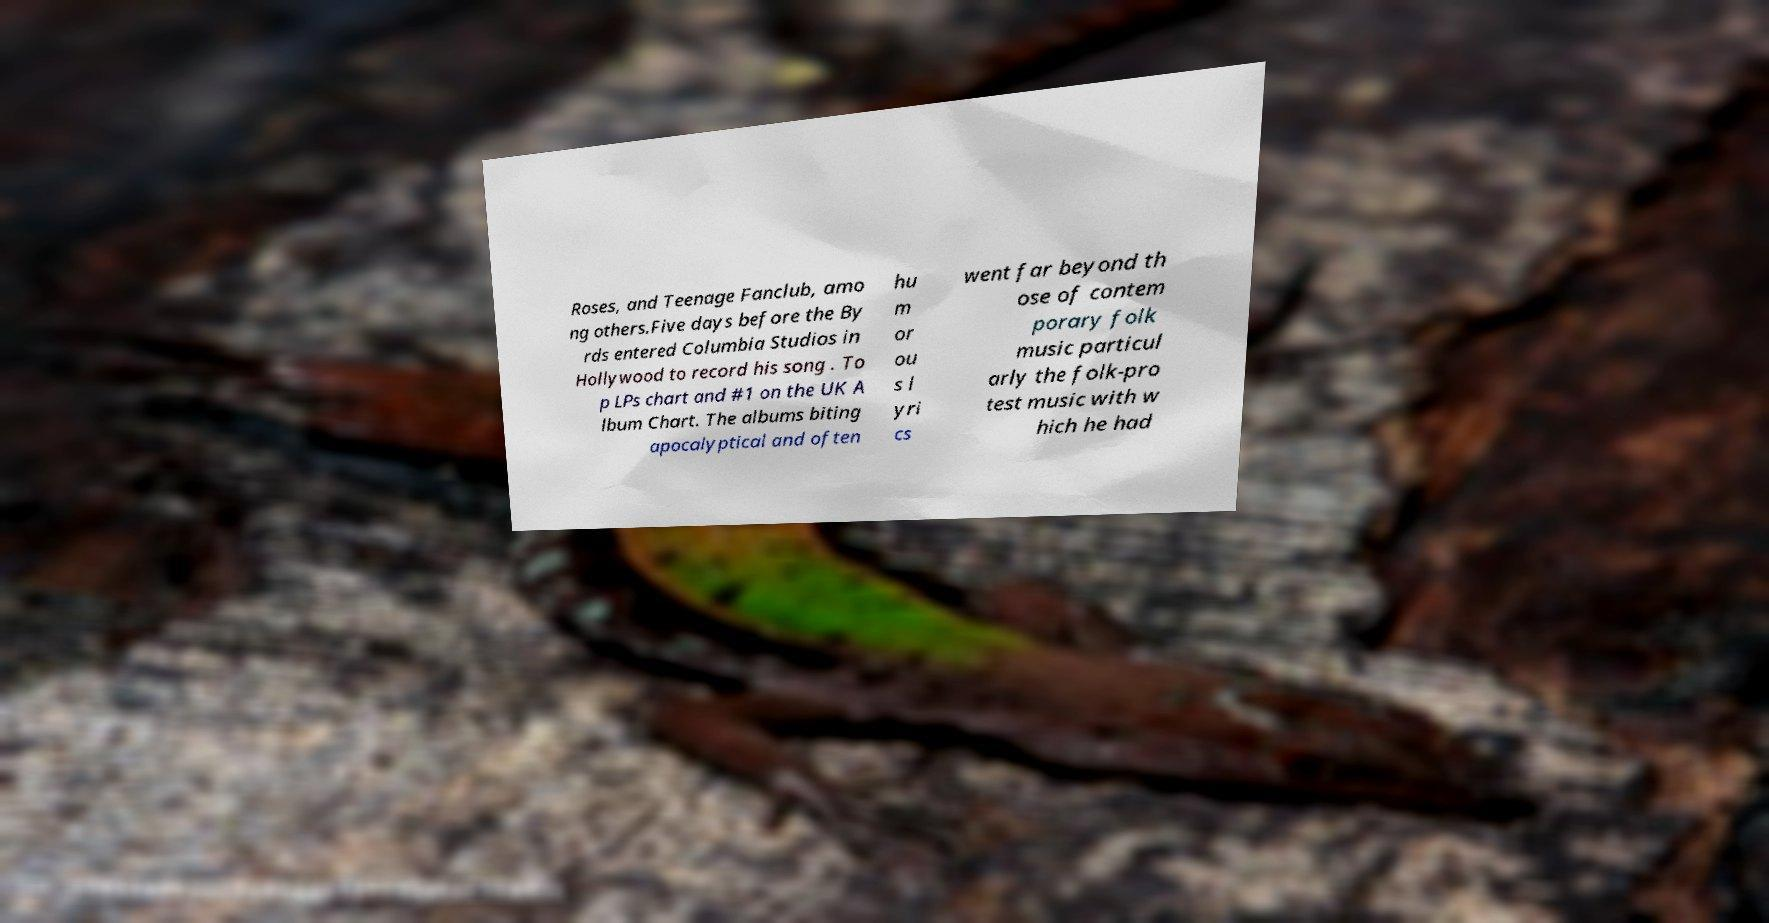Could you assist in decoding the text presented in this image and type it out clearly? Roses, and Teenage Fanclub, amo ng others.Five days before the By rds entered Columbia Studios in Hollywood to record his song . To p LPs chart and #1 on the UK A lbum Chart. The albums biting apocalyptical and often hu m or ou s l yri cs went far beyond th ose of contem porary folk music particul arly the folk-pro test music with w hich he had 